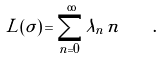Convert formula to latex. <formula><loc_0><loc_0><loc_500><loc_500>L ( \sigma ) \, = \sum _ { n = 0 } ^ { \infty } \lambda _ { n } \, n \quad .</formula> 